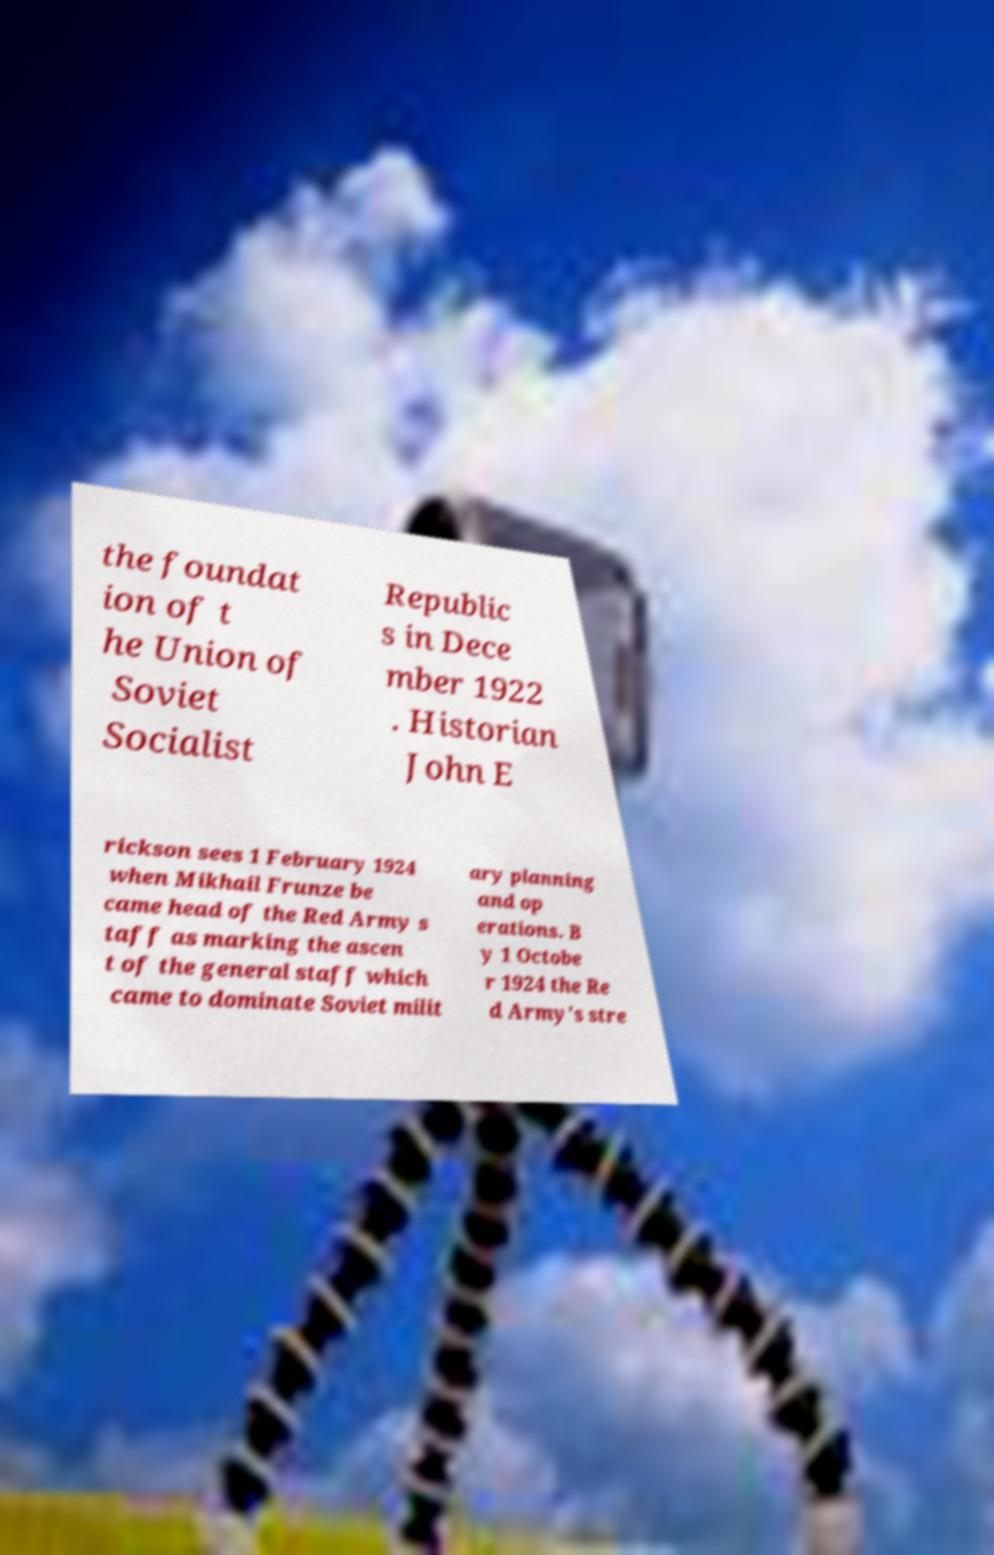Can you read and provide the text displayed in the image?This photo seems to have some interesting text. Can you extract and type it out for me? the foundat ion of t he Union of Soviet Socialist Republic s in Dece mber 1922 . Historian John E rickson sees 1 February 1924 when Mikhail Frunze be came head of the Red Army s taff as marking the ascen t of the general staff which came to dominate Soviet milit ary planning and op erations. B y 1 Octobe r 1924 the Re d Army's stre 